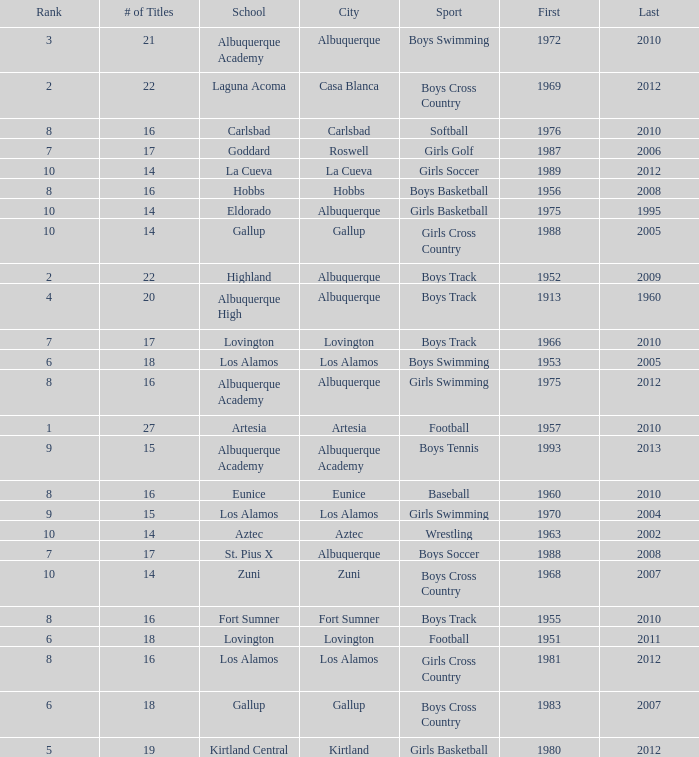What city is the school that had less than 17 titles in boys basketball with the last title being after 2005? Hobbs. 